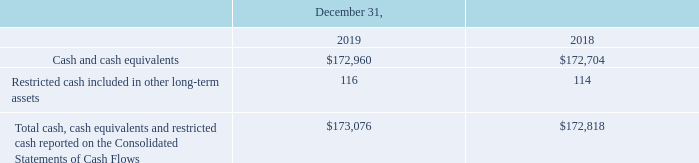Restricted Cash
The following table provides a reconciliation of cash, cash equivalents and restricted cash reported on the Consolidated Balance Sheets to the amounts reported on the Consolidated Statements of Cash Flows (in thousands):
As of December 31, 2019 and 2018, restricted cash included a security deposit that is set aside in a bank account and cannot be withdrawn by the Company under the terms of a lease agreement. The restriction will end upon the expiration of the lease.
What does the table provide? A reconciliation of cash, cash equivalents and restricted cash reported on the consolidated balance sheets to the amounts reported on the consolidated statements of cash flows. What does restricted cash include? Included a security deposit that is set aside in a bank account and cannot be withdrawn by the company under the terms of a lease agreement. What is the amount spent on cash and cash equivalents in 2019 and 2018 respectively?
Answer scale should be: thousand. 172,960, 172,704. What was the percentage change in Cash and cash equivalents from 2018 to 2019?
Answer scale should be: percent. (172,960-172,704)/172,704
Answer: 0.15. For how many years was the amount of total cash, cash equivalents and restricted cash reported on the Consolidated Statements of Cash Flows more than 150,000 thousand? 172,818##173,076
Answer: 2. What was the change in Restricted cash included in other long-term assets from 2018 to 2019?
Answer scale should be: thousand. 116-114 
Answer: 2. 